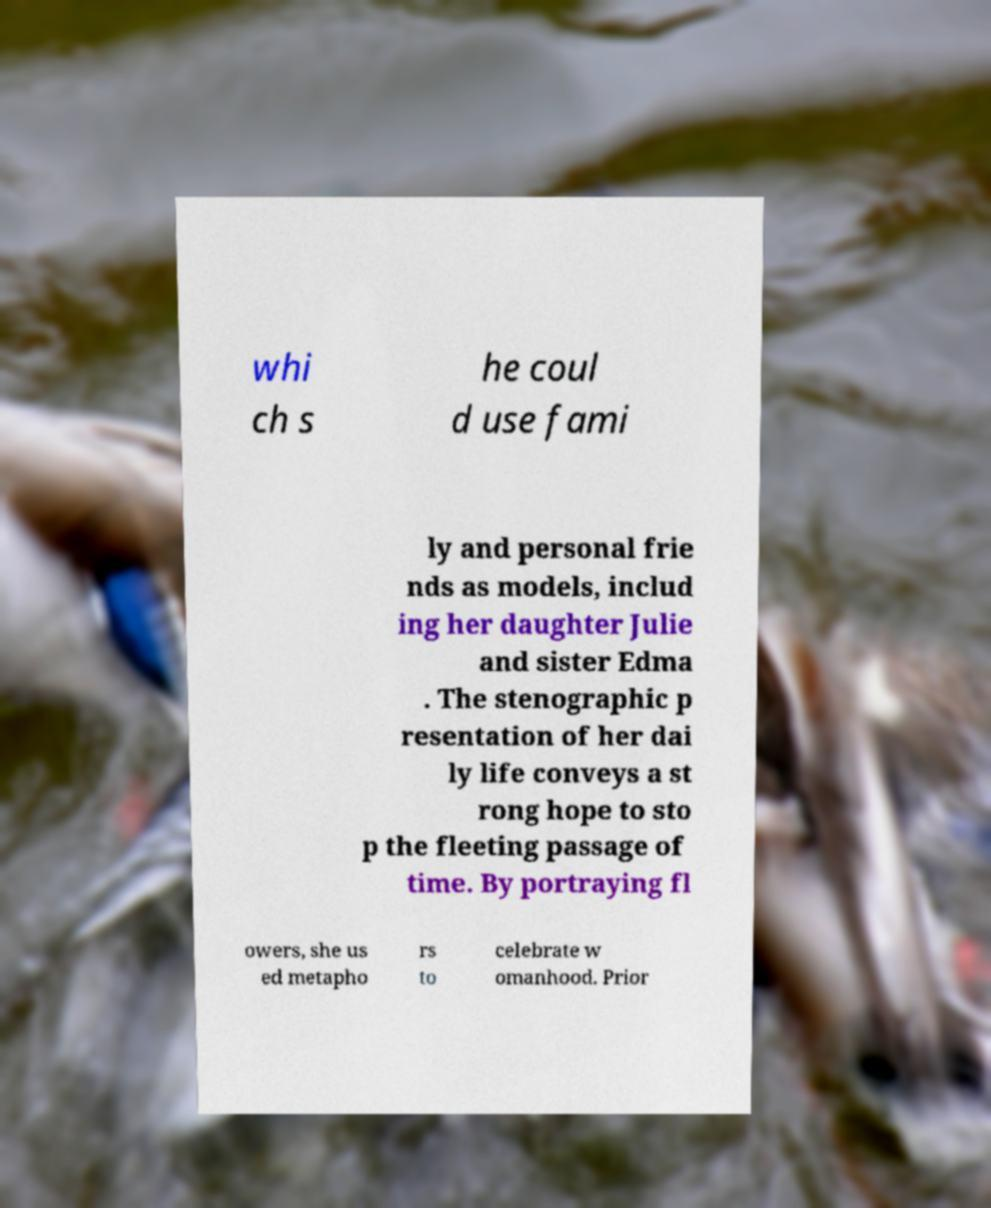I need the written content from this picture converted into text. Can you do that? whi ch s he coul d use fami ly and personal frie nds as models, includ ing her daughter Julie and sister Edma . The stenographic p resentation of her dai ly life conveys a st rong hope to sto p the fleeting passage of time. By portraying fl owers, she us ed metapho rs to celebrate w omanhood. Prior 